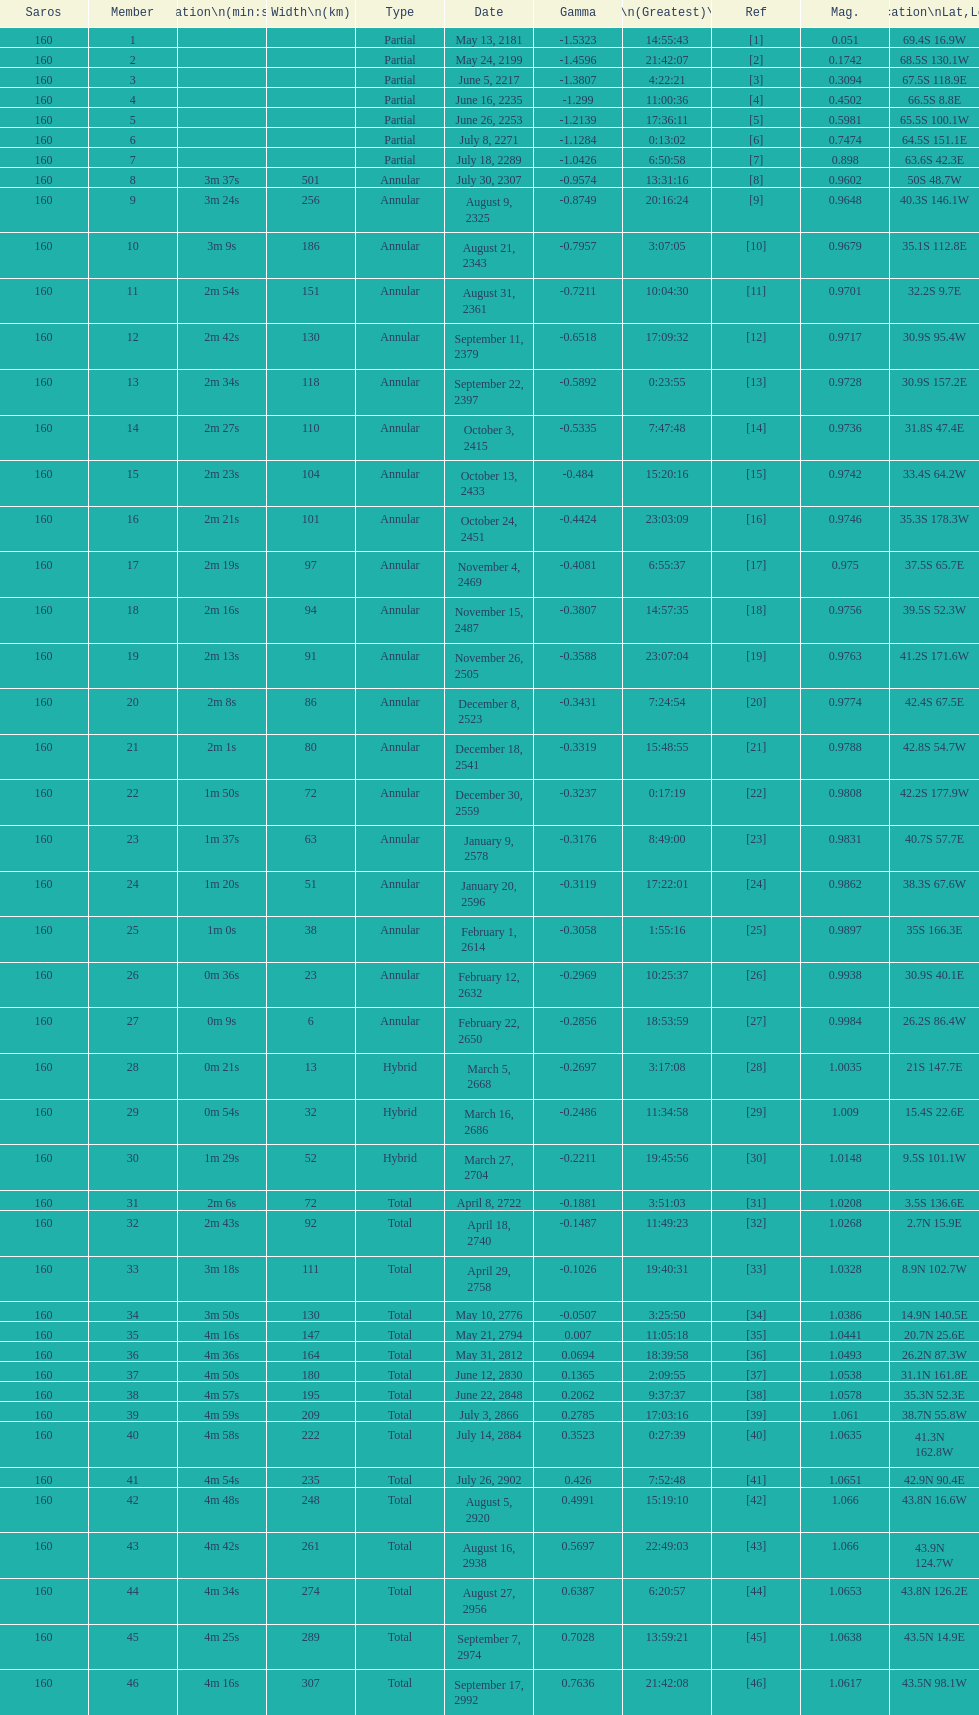Name one that has the same latitude as member number 12. 13. 